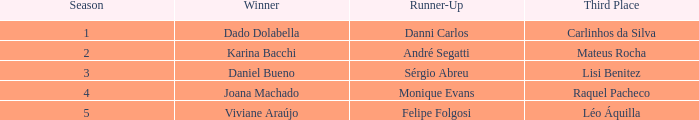In what season did Raquel Pacheco finish in third place? 4.0. 